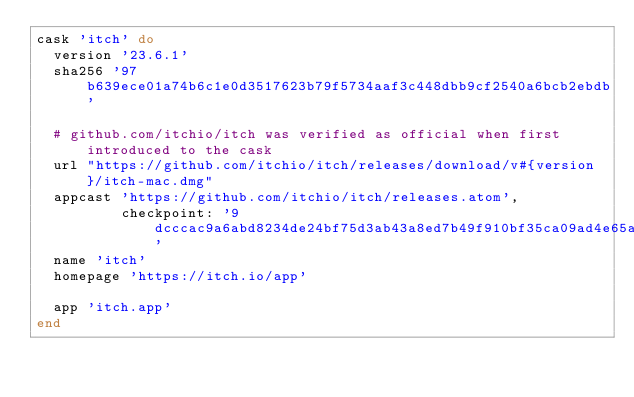Convert code to text. <code><loc_0><loc_0><loc_500><loc_500><_Ruby_>cask 'itch' do
  version '23.6.1'
  sha256 '97b639ece01a74b6c1e0d3517623b79f5734aaf3c448dbb9cf2540a6bcb2ebdb'

  # github.com/itchio/itch was verified as official when first introduced to the cask
  url "https://github.com/itchio/itch/releases/download/v#{version}/itch-mac.dmg"
  appcast 'https://github.com/itchio/itch/releases.atom',
          checkpoint: '9dcccac9a6abd8234de24bf75d3ab43a8ed7b49f910bf35ca09ad4e65a98bf27'
  name 'itch'
  homepage 'https://itch.io/app'

  app 'itch.app'
end
</code> 